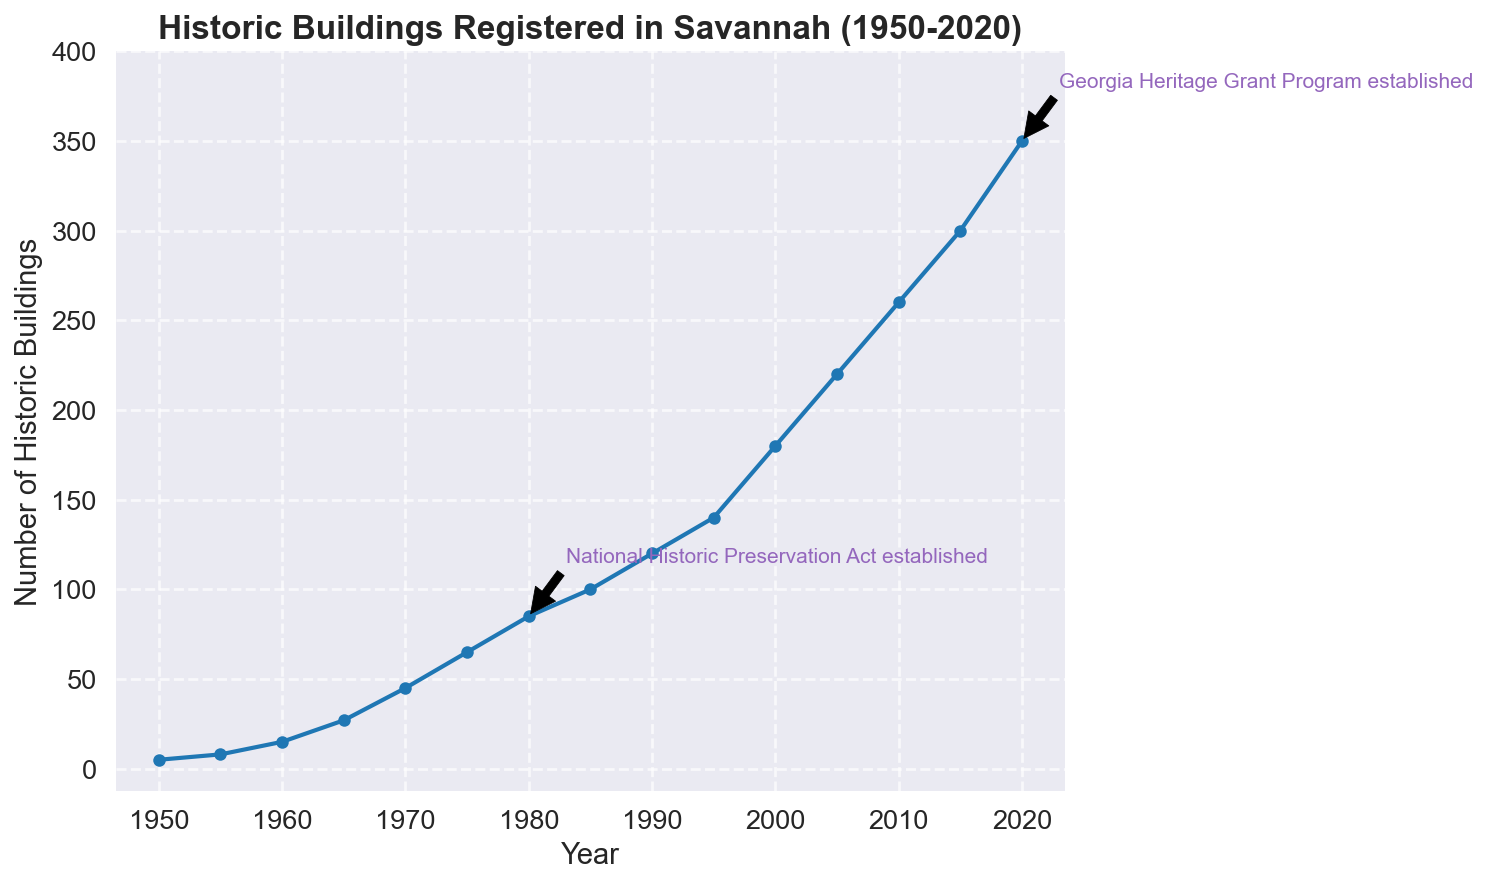How many historic buildings were registered in the year 2000? According to the figure, the number of historic buildings registered in the year 2000 is the y-value corresponding to the year 2000 on the x-axis.
Answer: 180 Which year saw the largest increase in the number of historic buildings registered compared to the previous year? By observing the steepness of the line between two consecutive years, the year with the largest increase is identified by the steepest slope. The steepest slope appears between 2000 and 2005.
Answer: 2005 How did the number of historic buildings change after the establishment of the National Historic Preservation Act in 1980? Look at the number of historic buildings registered before and after 1980. The number increases from 65 in 1975 to 85 in 1980 and continues to grow significantly afterward.
Answer: Increased Compare the number of historic buildings in 1960 and 1980. Referring to the y-values for the years 1960 and 1980, in 1960 there were 15 buildings, and in 1980 there were 85 buildings. Subtract to find the difference.
Answer: 70 more in 1980 What is the average number of historic buildings registered per decade from 1950 to 2020? Calculate the total number of buildings registered from 1950 to 2020, then divide by the number of decades (2020-1950)/10 = 7 decades. The sum is 5+8+15+27+45+65+85+100+120+140+180+220+260+300+350 = 1920. Divide 1920 by 7.
Answer: 274.29 What major preservation law was established in 2020, and what was its impact on the number of buildings? Referring to the annotation on the figure in 2020, the Georgia Heritage Grant Program was established, and the figure shows an increase from 300 in 2015 to 350 in 2020. Therefore, the law contributed to a rise.
Answer: Georgia Heritage Grant Program; Increase Which year marks the first annotated preservation law, and how many historic buildings were registered that year? The first annotation appears in 1980 for the National Historic Preservation Act established, with 85 historic buildings registered in that year.
Answer: 1980; 85 buildings If you sum the number of buildings registered in 1990, 2000, and 2010, what is the total? Add the y-values for these years: 120 (1990) + 180 (2000) + 260 (2010) = 560.
Answer: 560 How did the implementation of preservation laws affect the trend in building registrations over the years? Observing the trend line, steep increases in the number of historic buildings follow the annotations for preservation laws in 1980 and 2020, suggesting a positive influence on registrations.
Answer: Positive influence What was the rate of increase in the number of historic buildings from 1975 to 1980? Calculate the difference between 1980 and 1975 (85-65=20) and divide by the number of years (1980-1975=5), giving a rate of increase of 20/5 = 4 buildings per year.
Answer: 4 buildings/year 